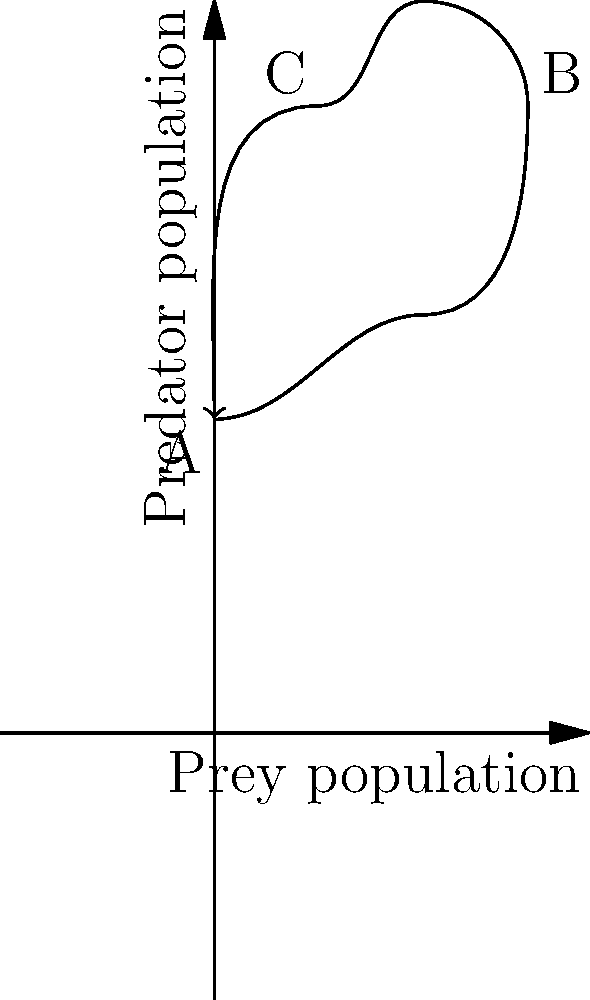As a principal encouraging collaboration between physics and biology teachers, you want to create an interdisciplinary lesson on population dynamics. The phase plane diagram above represents a predator-prey cycle. What does the movement from point A to point B in the diagram indicate about the populations of predators and prey? To analyze the phase plane diagram for the predator-prey cycle, we need to follow these steps:

1. Understand the axes:
   - The x-axis represents the prey population.
   - The y-axis represents the predator population.

2. Interpret point A:
   - Point A is located at a low value on both axes, indicating low populations of both predators and prey.

3. Interpret point B:
   - Point B is located at higher values on both axes compared to point A.

4. Analyze the movement from A to B:
   - Moving right on the x-axis indicates an increase in prey population.
   - Moving up on the y-axis indicates an increase in predator population.

5. Consider the biological interpretation:
   - As prey population increases, it provides more food for predators.
   - With more food available, the predator population can grow.

6. Relate to the interdisciplinary nature:
   - This demonstrates the application of mathematical models (phase plane diagrams) to biological systems (population dynamics).
   - It also shows how changes in one variable (prey population) can affect another (predator population), which is a concept familiar in physics (e.g., coupled systems).

Therefore, the movement from point A to point B indicates an increase in both predator and prey populations, with the prey population initially growing faster, followed by growth in the predator population.
Answer: Increase in both prey and predator populations 